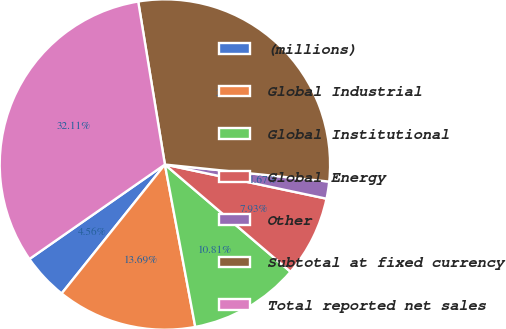Convert chart to OTSL. <chart><loc_0><loc_0><loc_500><loc_500><pie_chart><fcel>(millions)<fcel>Global Industrial<fcel>Global Institutional<fcel>Global Energy<fcel>Other<fcel>Subtotal at fixed currency<fcel>Total reported net sales<nl><fcel>4.56%<fcel>13.69%<fcel>10.81%<fcel>7.93%<fcel>1.67%<fcel>29.23%<fcel>32.11%<nl></chart> 